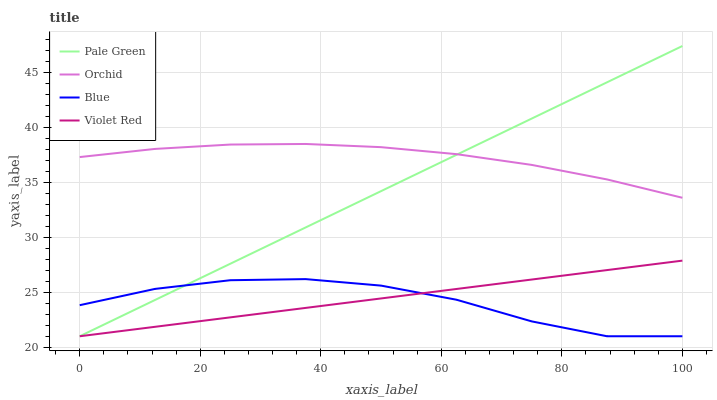Does Blue have the minimum area under the curve?
Answer yes or no. Yes. Does Orchid have the maximum area under the curve?
Answer yes or no. Yes. Does Violet Red have the minimum area under the curve?
Answer yes or no. No. Does Violet Red have the maximum area under the curve?
Answer yes or no. No. Is Violet Red the smoothest?
Answer yes or no. Yes. Is Blue the roughest?
Answer yes or no. Yes. Is Pale Green the smoothest?
Answer yes or no. No. Is Pale Green the roughest?
Answer yes or no. No. Does Orchid have the lowest value?
Answer yes or no. No. Does Violet Red have the highest value?
Answer yes or no. No. Is Violet Red less than Orchid?
Answer yes or no. Yes. Is Orchid greater than Blue?
Answer yes or no. Yes. Does Violet Red intersect Orchid?
Answer yes or no. No. 